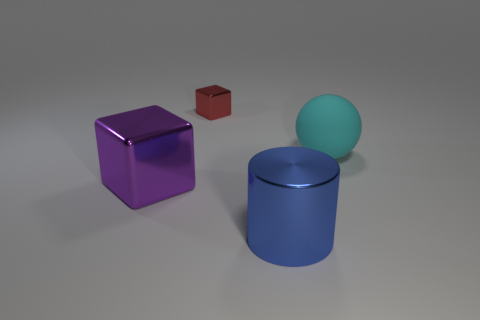How many tiny metallic cubes are left of the big metal thing to the right of the large shiny thing that is left of the large blue shiny cylinder?
Offer a terse response. 1. What shape is the large thing that is right of the purple thing and left of the cyan matte object?
Your answer should be compact. Cylinder. Are there fewer large purple objects in front of the big purple cube than large yellow metallic cylinders?
Offer a very short reply. No. What number of big things are rubber things or red shiny spheres?
Keep it short and to the point. 1. How big is the red thing?
Keep it short and to the point. Small. Is there any other thing that is the same material as the sphere?
Keep it short and to the point. No. There is a large rubber thing; how many red things are on the left side of it?
Keep it short and to the point. 1. What size is the other thing that is the same shape as the small metallic object?
Offer a terse response. Large. There is a metal thing that is in front of the tiny red metal object and on the right side of the big metallic cube; what size is it?
Offer a terse response. Large. What number of blue objects are either big shiny cylinders or big rubber cylinders?
Your answer should be compact. 1. 